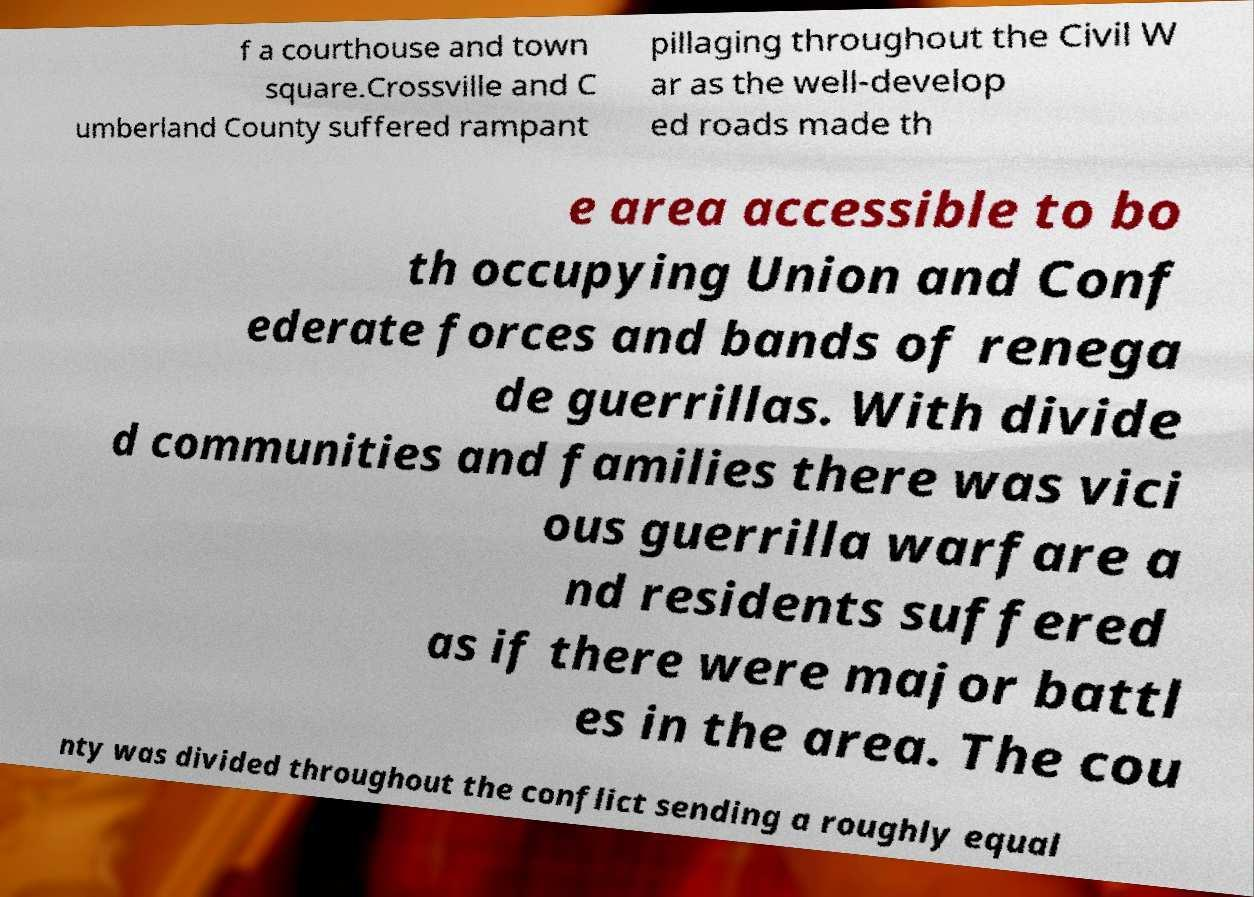There's text embedded in this image that I need extracted. Can you transcribe it verbatim? f a courthouse and town square.Crossville and C umberland County suffered rampant pillaging throughout the Civil W ar as the well-develop ed roads made th e area accessible to bo th occupying Union and Conf ederate forces and bands of renega de guerrillas. With divide d communities and families there was vici ous guerrilla warfare a nd residents suffered as if there were major battl es in the area. The cou nty was divided throughout the conflict sending a roughly equal 